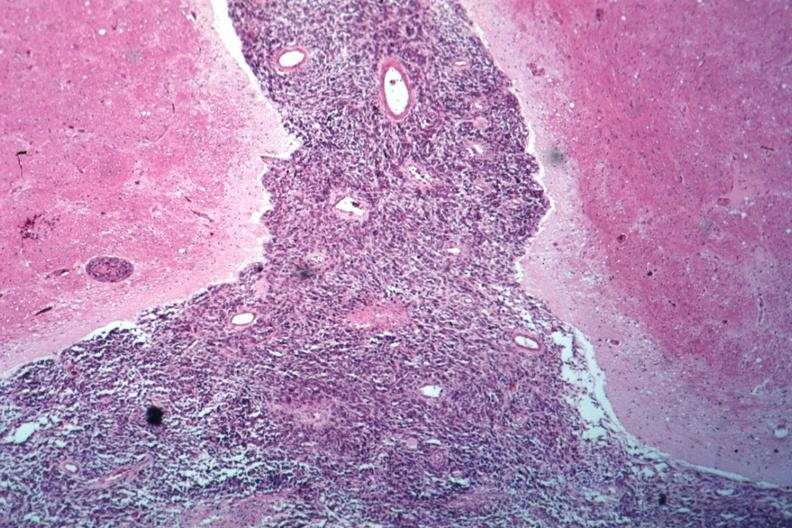s history present?
Answer the question using a single word or phrase. No 